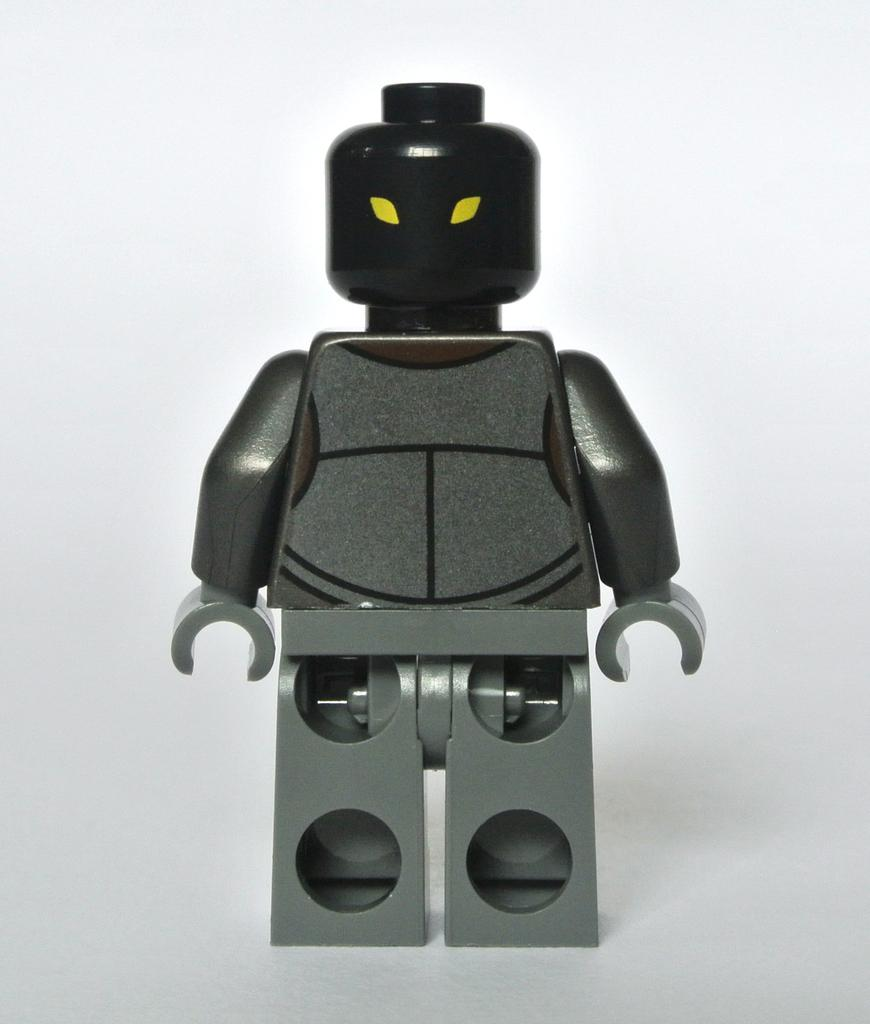What object can be seen in the image? There is a toy in the image. On what surface is the toy placed? The toy is placed on a white surface. Is the dog in the image paying for the toy with a credit card? There is no dog or credit card present in the image, so it is not possible to answer that question. 